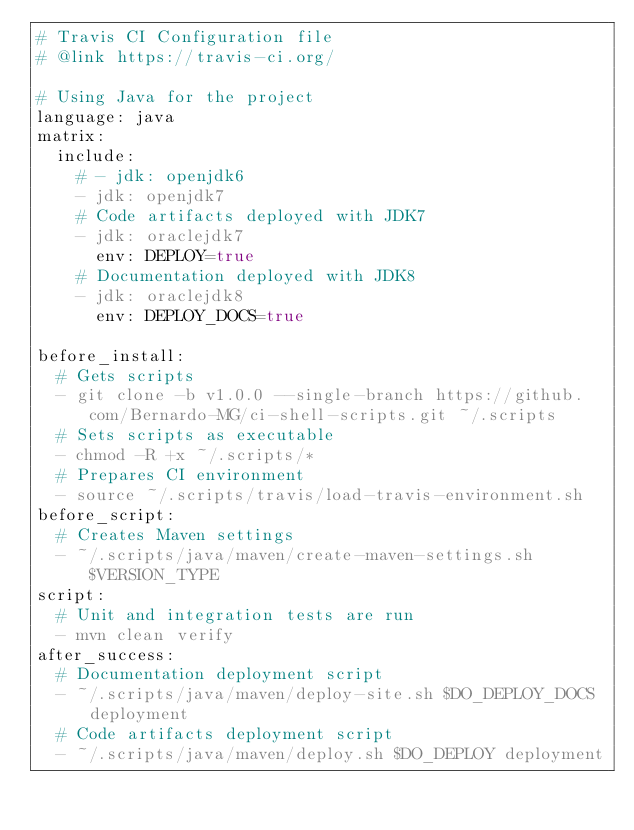Convert code to text. <code><loc_0><loc_0><loc_500><loc_500><_YAML_># Travis CI Configuration file
# @link https://travis-ci.org/

# Using Java for the project
language: java
matrix:
  include:
    # - jdk: openjdk6
    - jdk: openjdk7
    # Code artifacts deployed with JDK7
    - jdk: oraclejdk7
      env: DEPLOY=true
    # Documentation deployed with JDK8
    - jdk: oraclejdk8
      env: DEPLOY_DOCS=true

before_install:
  # Gets scripts
  - git clone -b v1.0.0 --single-branch https://github.com/Bernardo-MG/ci-shell-scripts.git ~/.scripts
  # Sets scripts as executable
  - chmod -R +x ~/.scripts/*
  # Prepares CI environment
  - source ~/.scripts/travis/load-travis-environment.sh
before_script:
  # Creates Maven settings
  - ~/.scripts/java/maven/create-maven-settings.sh $VERSION_TYPE
script:
  # Unit and integration tests are run
  - mvn clean verify
after_success:
  # Documentation deployment script
  - ~/.scripts/java/maven/deploy-site.sh $DO_DEPLOY_DOCS deployment
  # Code artifacts deployment script
  - ~/.scripts/java/maven/deploy.sh $DO_DEPLOY deployment
</code> 